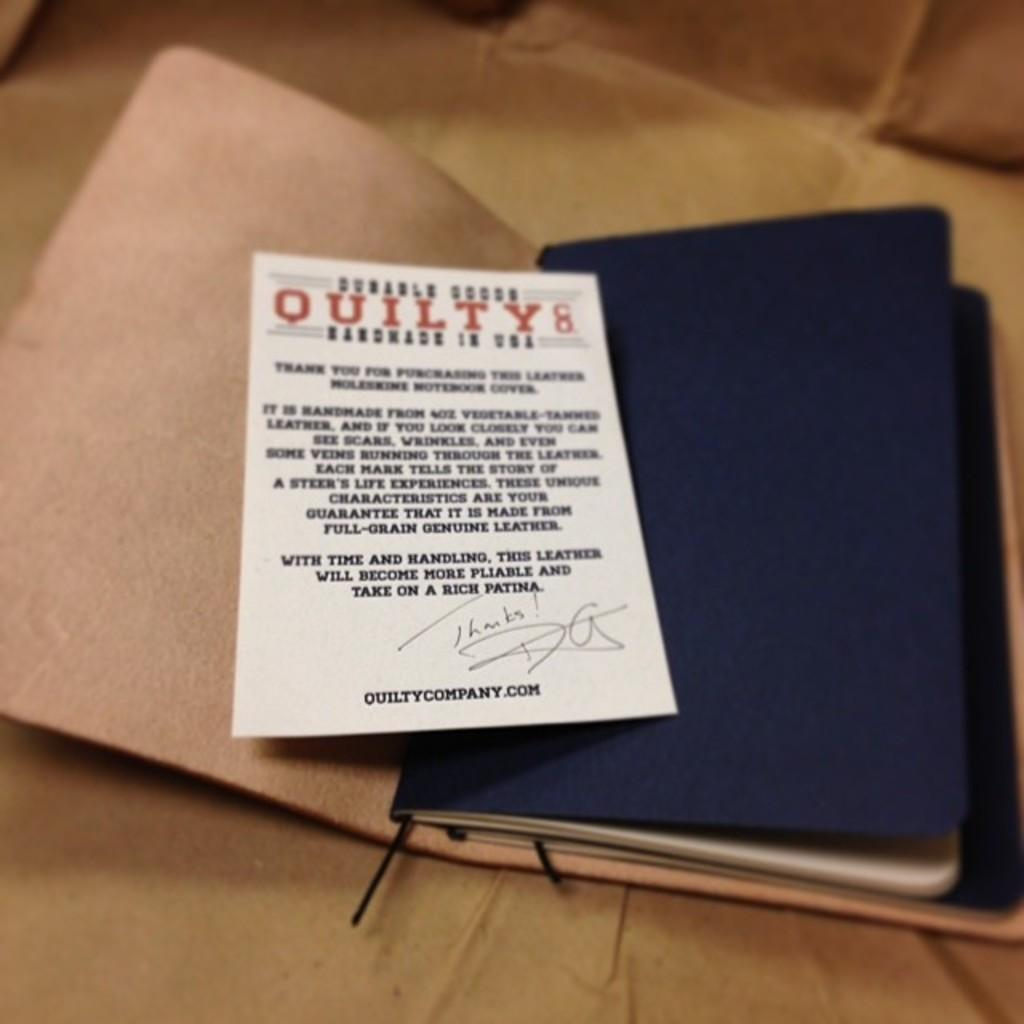<image>
Relay a brief, clear account of the picture shown. A blue notebook has a card on it that says Quilty Handmade In USA. 